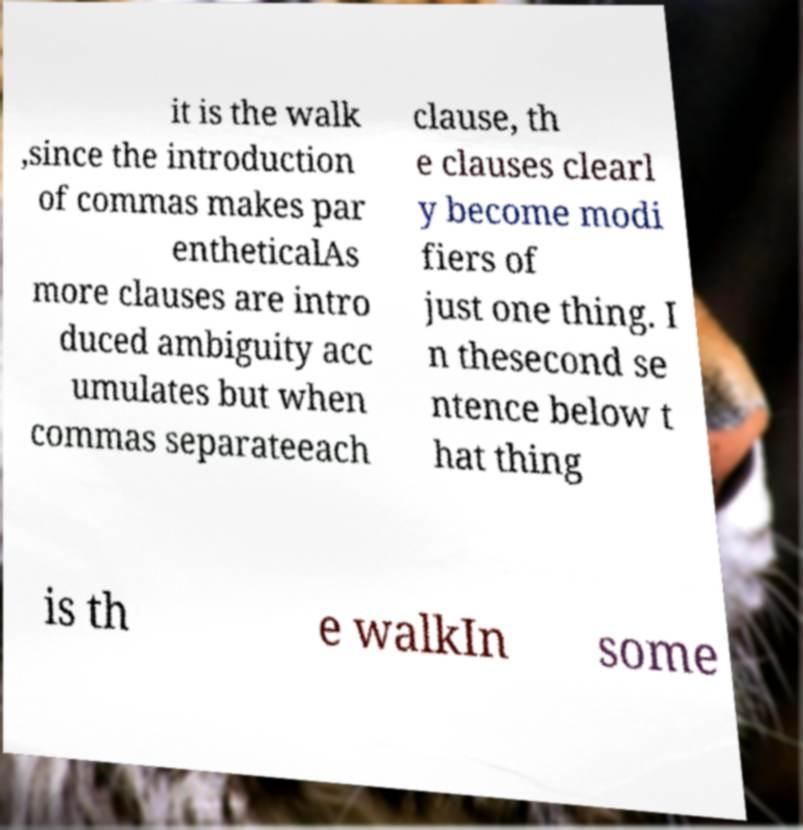For documentation purposes, I need the text within this image transcribed. Could you provide that? it is the walk ,since the introduction of commas makes par entheticalAs more clauses are intro duced ambiguity acc umulates but when commas separateeach clause, th e clauses clearl y become modi fiers of just one thing. I n thesecond se ntence below t hat thing is th e walkIn some 